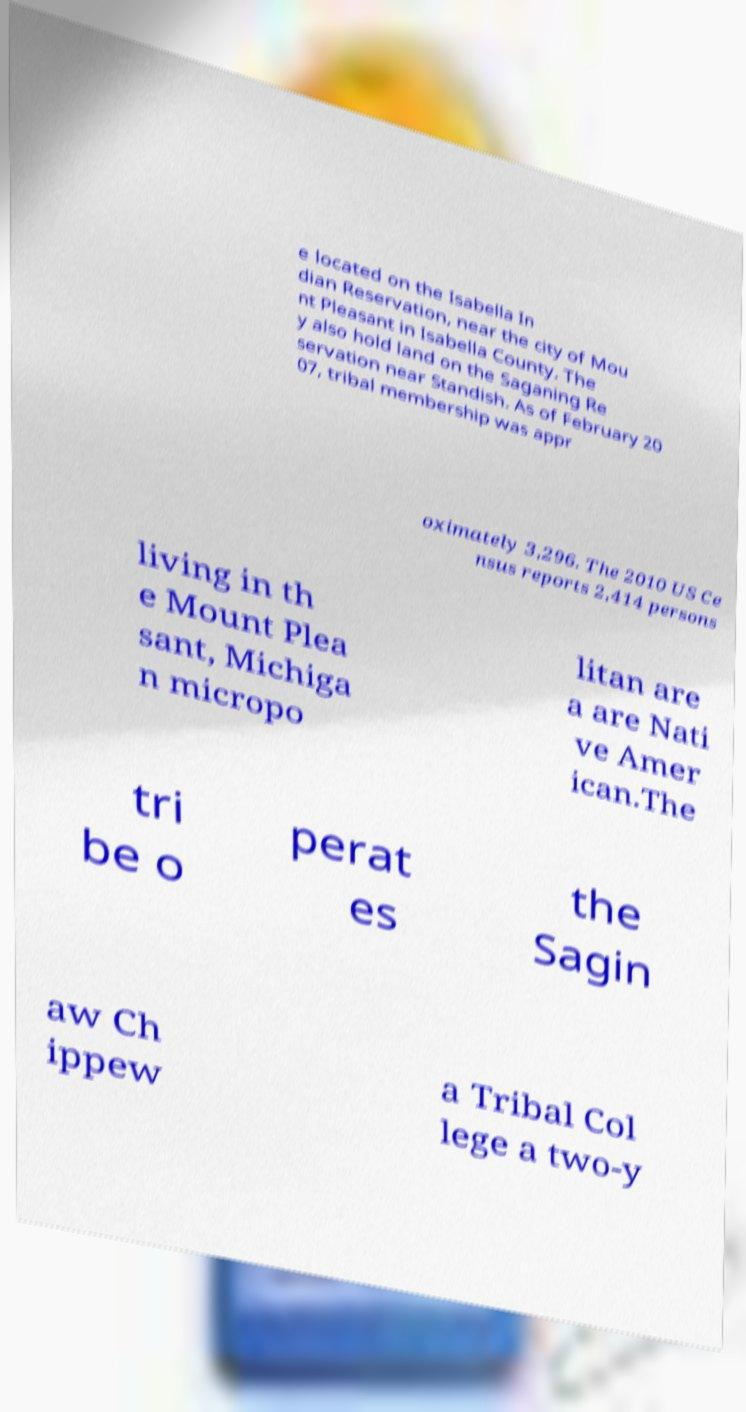There's text embedded in this image that I need extracted. Can you transcribe it verbatim? e located on the Isabella In dian Reservation, near the city of Mou nt Pleasant in Isabella County. The y also hold land on the Saganing Re servation near Standish. As of February 20 07, tribal membership was appr oximately 3,296. The 2010 US Ce nsus reports 2,414 persons living in th e Mount Plea sant, Michiga n micropo litan are a are Nati ve Amer ican.The tri be o perat es the Sagin aw Ch ippew a Tribal Col lege a two-y 